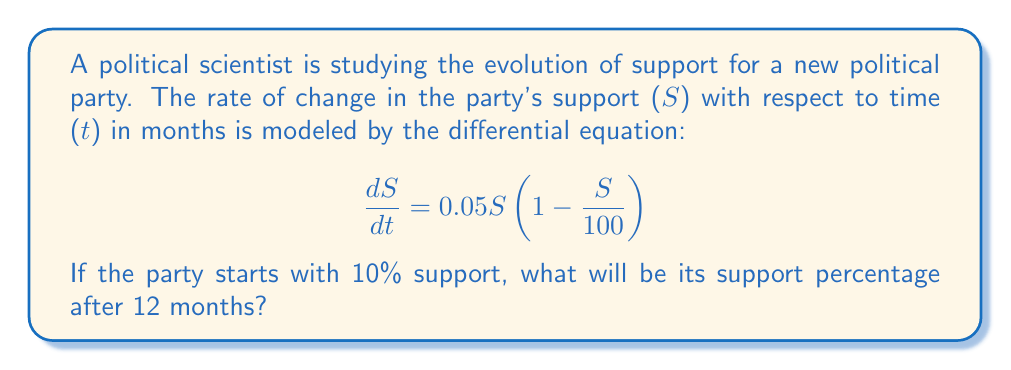Can you answer this question? To solve this problem, we need to use the logistic growth model, which is a first-order differential equation. Let's approach this step-by-step:

1) The given differential equation is in the form of the logistic growth model:
   $$\frac{dS}{dt} = rS(1 - \frac{S}{K})$$
   where $r = 0.05$ is the growth rate and $K = 100$ is the carrying capacity.

2) The solution to this differential equation is:
   $$S(t) = \frac{K}{1 + (\frac{K}{S_0} - 1)e^{-rt}}$$
   where $S_0$ is the initial support.

3) We are given:
   $K = 100$
   $r = 0.05$
   $S_0 = 10$
   $t = 12$

4) Let's substitute these values into our solution:
   $$S(12) = \frac{100}{1 + (\frac{100}{10} - 1)e^{-0.05(12)}}$$

5) Simplify:
   $$S(12) = \frac{100}{1 + 9e^{-0.6}}$$

6) Calculate:
   $$S(12) = \frac{100}{1 + 9(0.5488)}$$
   $$S(12) = \frac{100}{5.9392}$$
   $$S(12) \approx 16.84$$

Therefore, after 12 months, the party's support will be approximately 16.84%.
Answer: 16.84% 